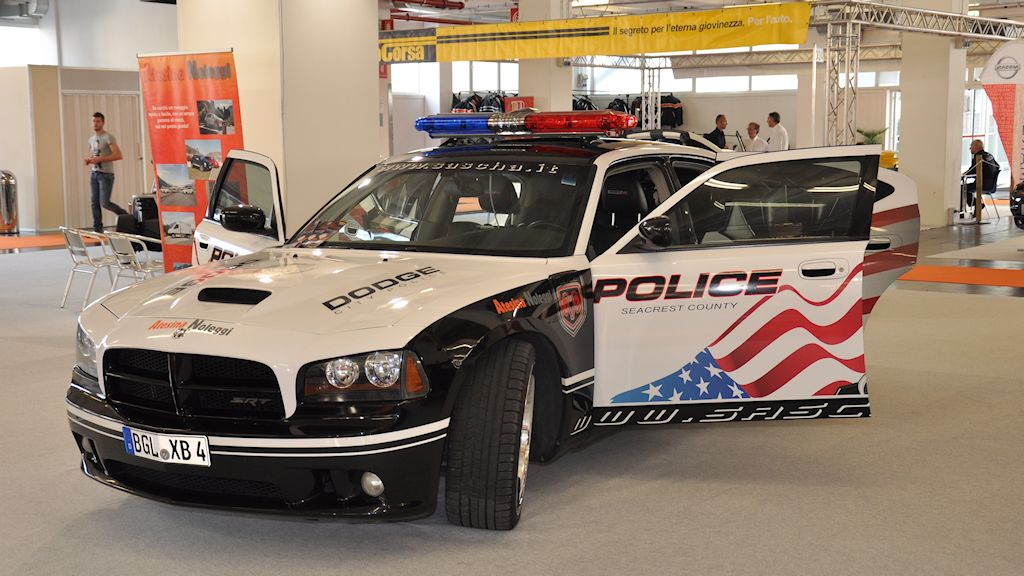If this vehicle were to be featured in a movie, what kind of scene or scenario would it be involved in? In a movie, this vehicle would likely be featured in a high-speed chase through a bustling city, showcasing its power and agility as it maneuvers through traffic to pursue a dangerous criminal. The scene would highlight its flashing lights and sirens, drawing attention as it speeds past iconic landmarks. It could also be part of a dramatic rescue operation, arriving at a tense standoff where the officers inside use its cutting-edge communication equipment to negotiate with a suspect. Throughout the film, the car itself would symbolize the relentless pursuit of justice and commitment to law and order. 